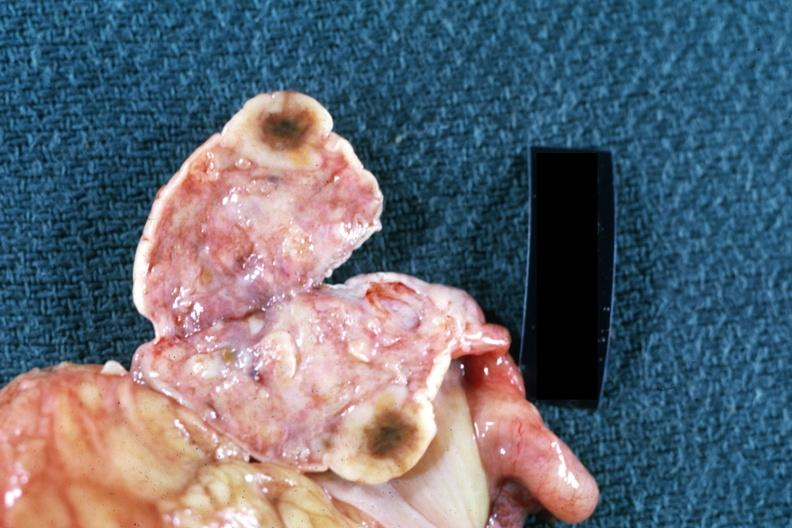s glioma present?
Answer the question using a single word or phrase. No 